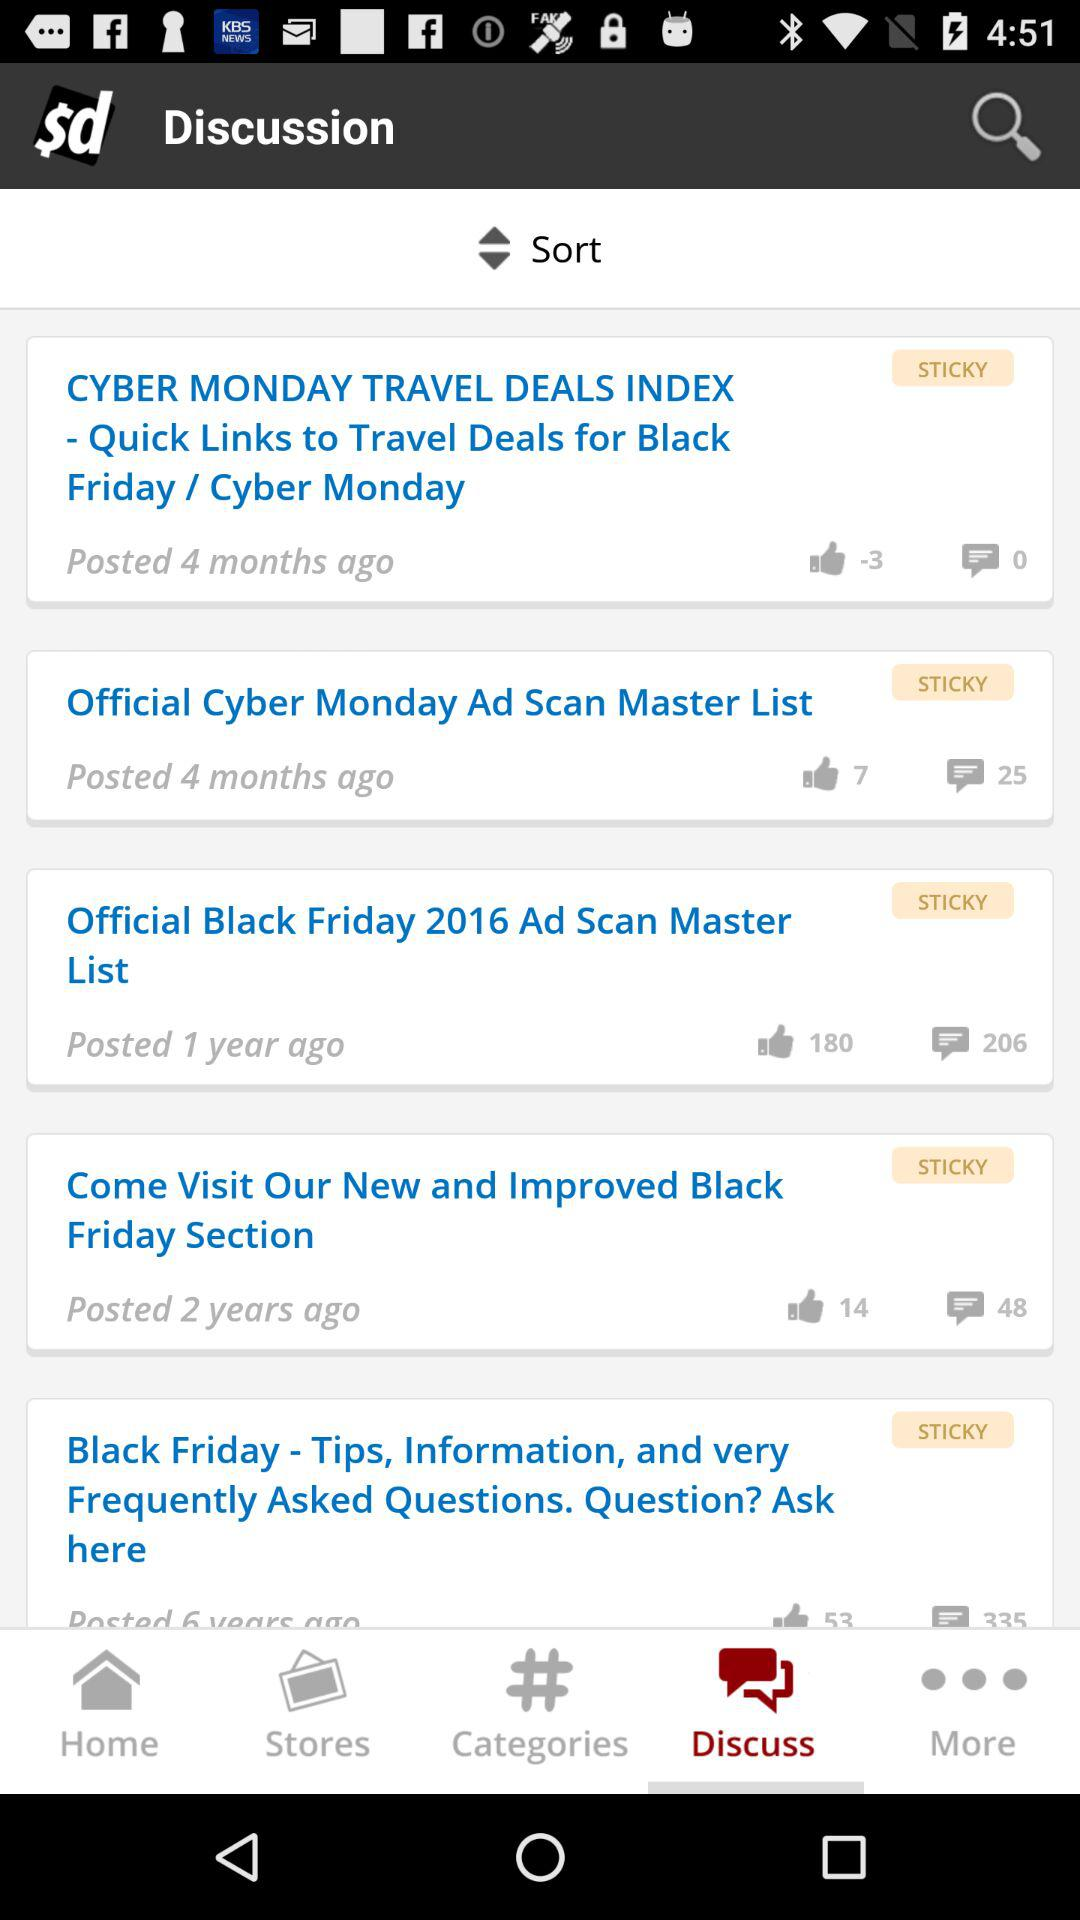How many likes of the post which was posted 1 year ago? There are 180 likes of the post, which was posted 1 year ago. 